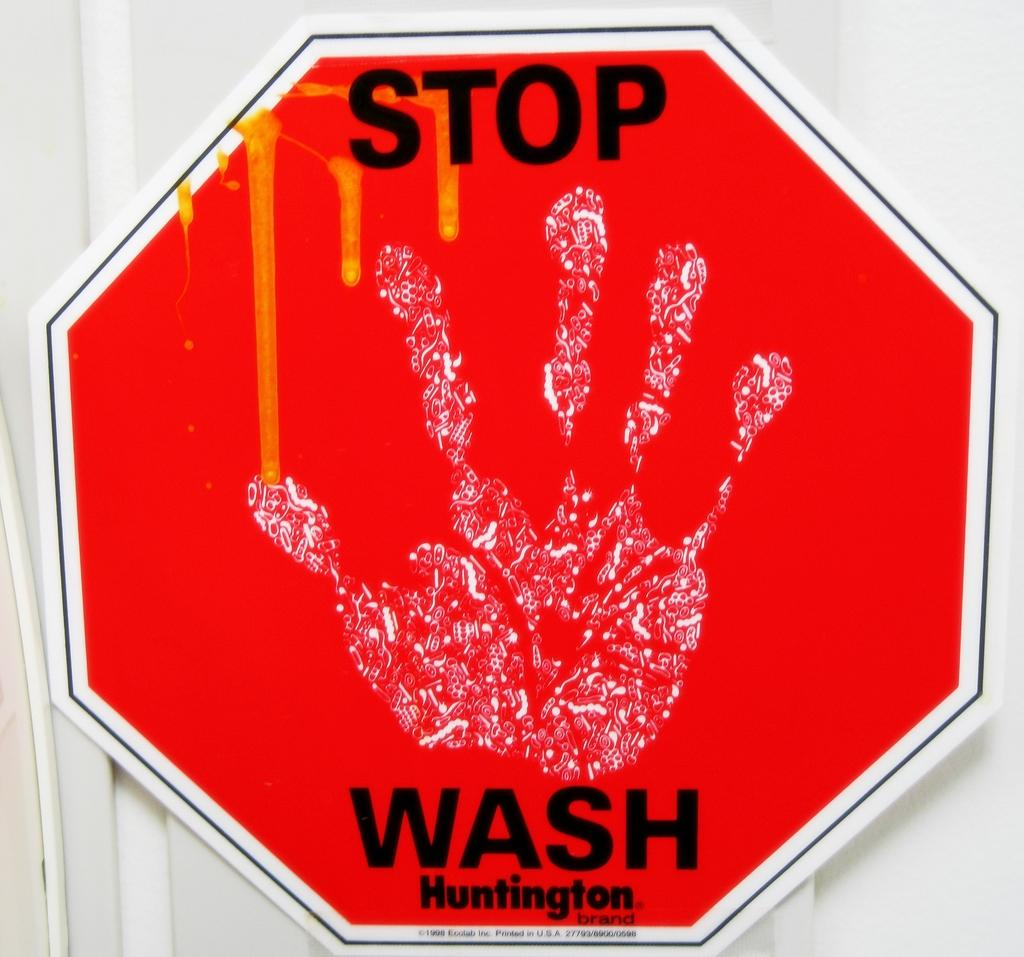<image>
Share a concise interpretation of the image provided. A red octagon sign that says STOP WASH and Huntington with a white hand print in the middle. 